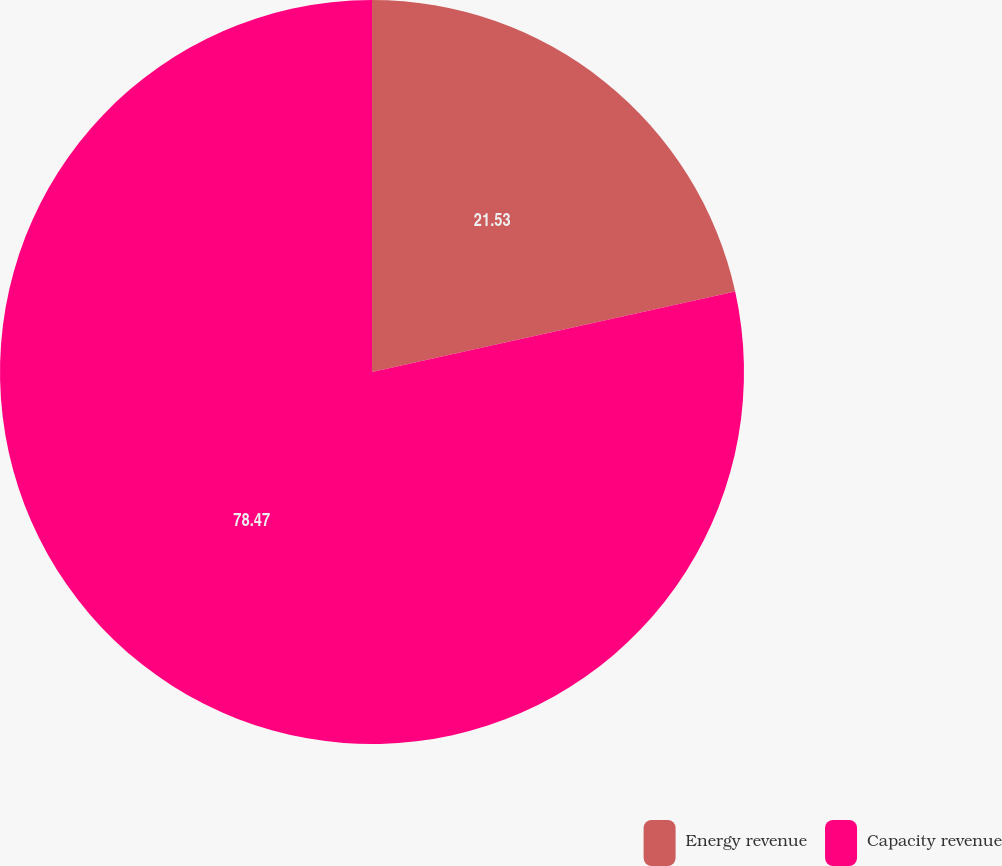Convert chart. <chart><loc_0><loc_0><loc_500><loc_500><pie_chart><fcel>Energy revenue<fcel>Capacity revenue<nl><fcel>21.53%<fcel>78.47%<nl></chart> 